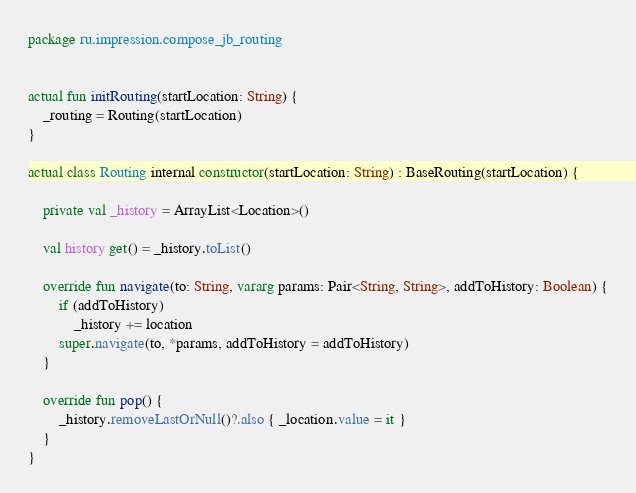Convert code to text. <code><loc_0><loc_0><loc_500><loc_500><_Kotlin_>package ru.impression.compose_jb_routing


actual fun initRouting(startLocation: String) {
    _routing = Routing(startLocation)
}

actual class Routing internal constructor(startLocation: String) : BaseRouting(startLocation) {

    private val _history = ArrayList<Location>()

    val history get() = _history.toList()

    override fun navigate(to: String, vararg params: Pair<String, String>, addToHistory: Boolean) {
        if (addToHistory)
            _history += location
        super.navigate(to, *params, addToHistory = addToHistory)
    }

    override fun pop() {
        _history.removeLastOrNull()?.also { _location.value = it }
    }
}</code> 